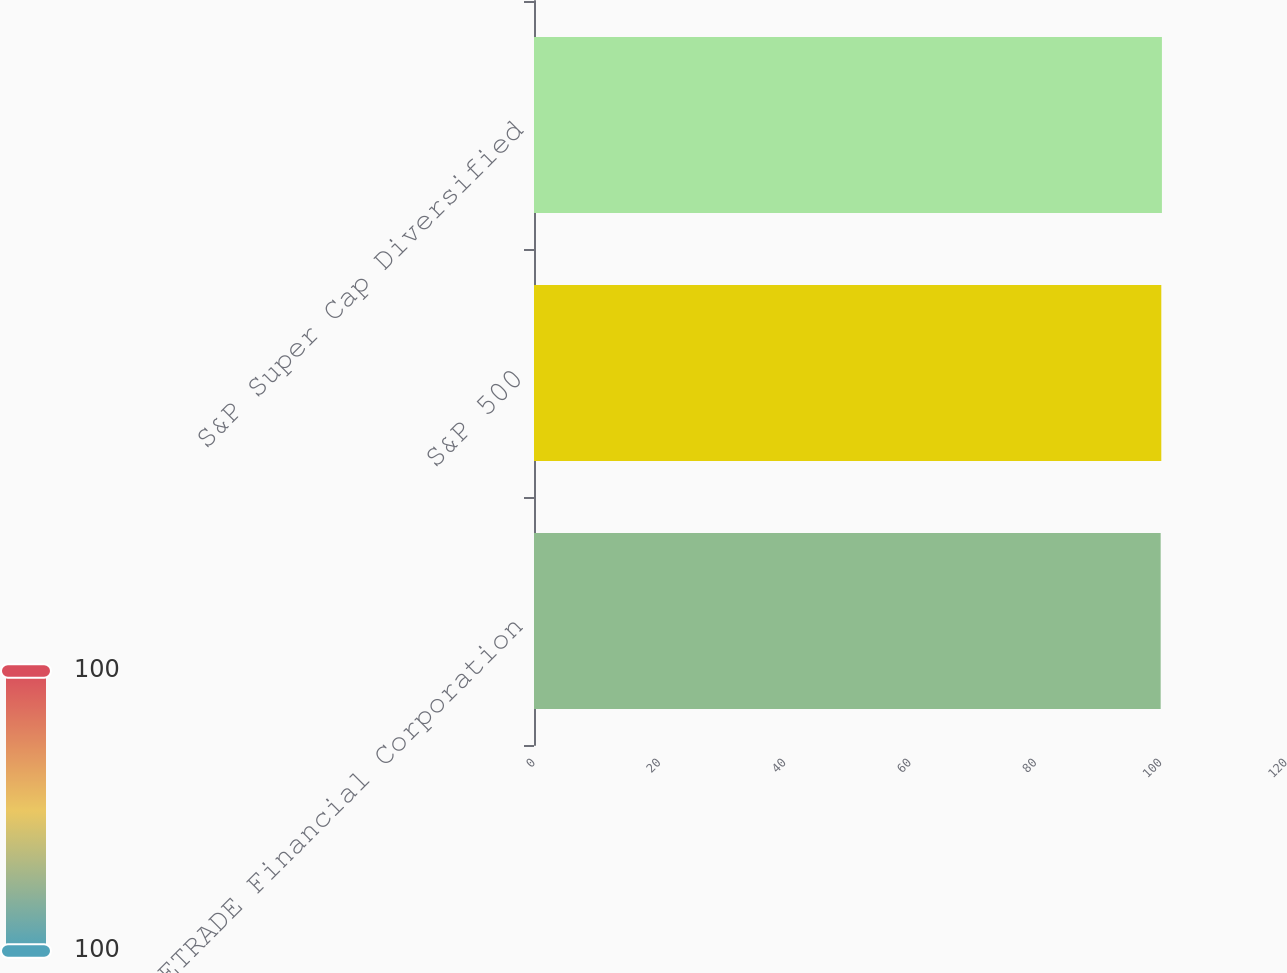Convert chart to OTSL. <chart><loc_0><loc_0><loc_500><loc_500><bar_chart><fcel>ETRADE Financial Corporation<fcel>S&P 500<fcel>S&P Super Cap Diversified<nl><fcel>100<fcel>100.1<fcel>100.2<nl></chart> 